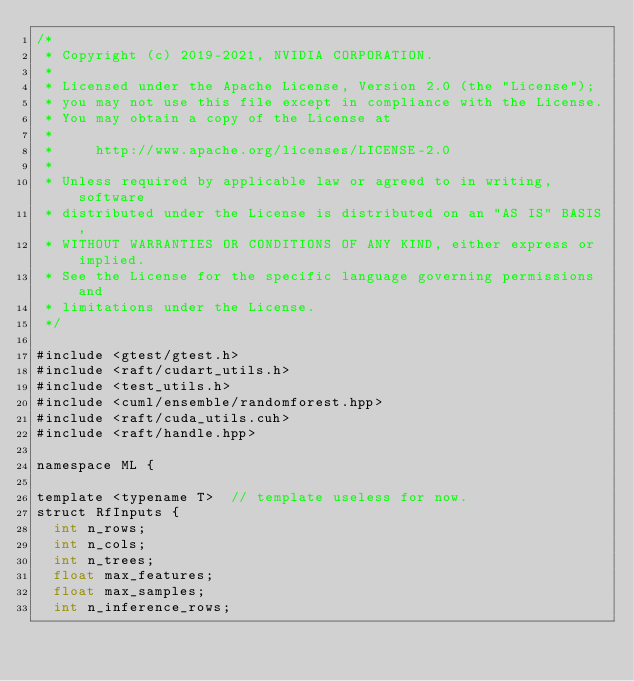<code> <loc_0><loc_0><loc_500><loc_500><_Cuda_>/*
 * Copyright (c) 2019-2021, NVIDIA CORPORATION.
 *
 * Licensed under the Apache License, Version 2.0 (the "License");
 * you may not use this file except in compliance with the License.
 * You may obtain a copy of the License at
 *
 *     http://www.apache.org/licenses/LICENSE-2.0
 *
 * Unless required by applicable law or agreed to in writing, software
 * distributed under the License is distributed on an "AS IS" BASIS,
 * WITHOUT WARRANTIES OR CONDITIONS OF ANY KIND, either express or implied.
 * See the License for the specific language governing permissions and
 * limitations under the License.
 */

#include <gtest/gtest.h>
#include <raft/cudart_utils.h>
#include <test_utils.h>
#include <cuml/ensemble/randomforest.hpp>
#include <raft/cuda_utils.cuh>
#include <raft/handle.hpp>

namespace ML {

template <typename T>  // template useless for now.
struct RfInputs {
  int n_rows;
  int n_cols;
  int n_trees;
  float max_features;
  float max_samples;
  int n_inference_rows;</code> 